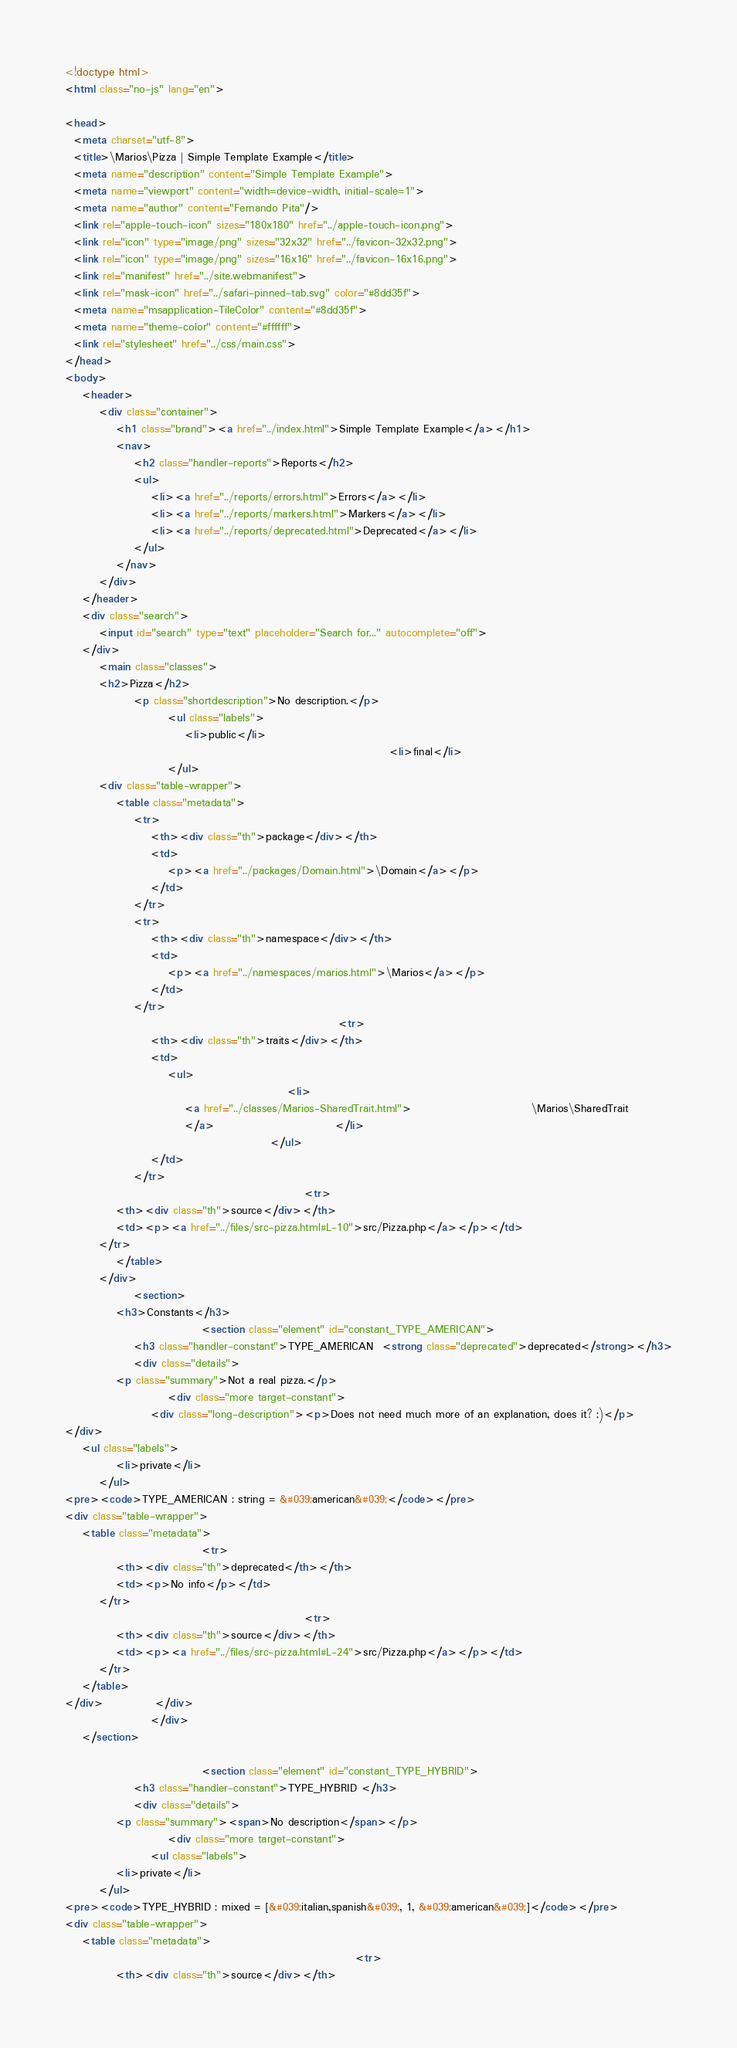<code> <loc_0><loc_0><loc_500><loc_500><_HTML_><!doctype html>
<html class="no-js" lang="en">

<head>
  <meta charset="utf-8">
  <title>\Marios\Pizza | Simple Template Example</title>
  <meta name="description" content="Simple Template Example">
  <meta name="viewport" content="width=device-width, initial-scale=1">
  <meta name="author" content="Fernando Pita"/>
  <link rel="apple-touch-icon" sizes="180x180" href="../apple-touch-icon.png">
  <link rel="icon" type="image/png" sizes="32x32" href="../favicon-32x32.png">
  <link rel="icon" type="image/png" sizes="16x16" href="../favicon-16x16.png">
  <link rel="manifest" href="../site.webmanifest">
  <link rel="mask-icon" href="../safari-pinned-tab.svg" color="#8dd35f">
  <meta name="msapplication-TileColor" content="#8dd35f">
  <meta name="theme-color" content="#ffffff">
  <link rel="stylesheet" href="../css/main.css">
</head>
<body>
    <header>
        <div class="container">
            <h1 class="brand"><a href="../index.html">Simple Template Example</a></h1>
            <nav>
                <h2 class="handler-reports">Reports</h2>
                <ul>
                    <li><a href="../reports/errors.html">Errors</a></li>
                    <li><a href="../reports/markers.html">Markers</a></li>
                    <li><a href="../reports/deprecated.html">Deprecated</a></li>
                </ul>
            </nav>
        </div>
    </header>
    <div class="search">
        <input id="search" type="text" placeholder="Search for..." autocomplete="off">
    </div>
        <main class="classes">
        <h2>Pizza</h2>
                <p class="shortdescription">No description.</p>
                        <ul class="labels">
                            <li>public</li>
                                                                            <li>final</li>
                        </ul>
        <div class="table-wrapper">
            <table class="metadata">
                <tr>
                    <th><div class="th">package</div></th>
                    <td>
                        <p><a href="../packages/Domain.html">\Domain</a></p>
                    </td>
                </tr>
                <tr>
                    <th><div class="th">namespace</div></th>
                    <td>
                        <p><a href="../namespaces/marios.html">\Marios</a></p>
                    </td>
                </tr>
                                                                <tr>
                    <th><div class="th">traits</div></th>
                    <td>
                        <ul>
                                                    <li>
                            <a href="../classes/Marios-SharedTrait.html">                            \Marios\SharedTrait
                            </a>                            </li>
                                                </ul>
                    </td>
                </tr>
                                                        <tr>
            <th><div class="th">source</div></th>
            <td><p><a href="../files/src-pizza.html#L-10">src/Pizza.php</a></p></td>
        </tr>
            </table>
        </div>
                <section>
            <h3>Constants</h3>
                                <section class="element" id="constant_TYPE_AMERICAN">
                <h3 class="handler-constant">TYPE_AMERICAN  <strong class="deprecated">deprecated</strong></h3>
                <div class="details">
            <p class="summary">Not a real pizza.</p>
                        <div class="more target-constant">
                    <div class="long-description"><p>Does not need much more of an explanation, does it? ;)</p>
</div>
    <ul class="labels">
            <li>private</li>
        </ul>
<pre><code>TYPE_AMERICAN : string = &#039;american&#039;</code></pre>
<div class="table-wrapper">
    <table class="metadata">
                                <tr>
            <th><div class="th">deprecated</th></th>
            <td><p>No info</p></td>
        </tr>
                                                        <tr>
            <th><div class="th">source</div></th>
            <td><p><a href="../files/src-pizza.html#L-24">src/Pizza.php</a></p></td>
        </tr>
    </table>
</div>            </div>
                    </div>
    </section>

                                <section class="element" id="constant_TYPE_HYBRID">
                <h3 class="handler-constant">TYPE_HYBRID </h3>
                <div class="details">
            <p class="summary"><span>No description</span></p>
                        <div class="more target-constant">
                    <ul class="labels">
            <li>private</li>
        </ul>
<pre><code>TYPE_HYBRID : mixed = [&#039;italian,spanish&#039;, 1, &#039;american&#039;]</code></pre>
<div class="table-wrapper">
    <table class="metadata">
                                                                    <tr>
            <th><div class="th">source</div></th></code> 